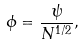Convert formula to latex. <formula><loc_0><loc_0><loc_500><loc_500>\phi = \frac { \psi } { N ^ { 1 / 2 } } ,</formula> 